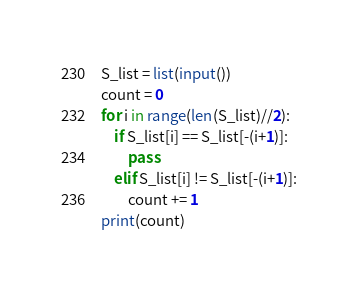<code> <loc_0><loc_0><loc_500><loc_500><_Python_>S_list = list(input())
count = 0
for i in range(len(S_list)//2):
    if S_list[i] == S_list[-(i+1)]:
        pass
    elif S_list[i] != S_list[-(i+1)]:
        count += 1
print(count)</code> 